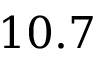<formula> <loc_0><loc_0><loc_500><loc_500>1 0 . 7</formula> 